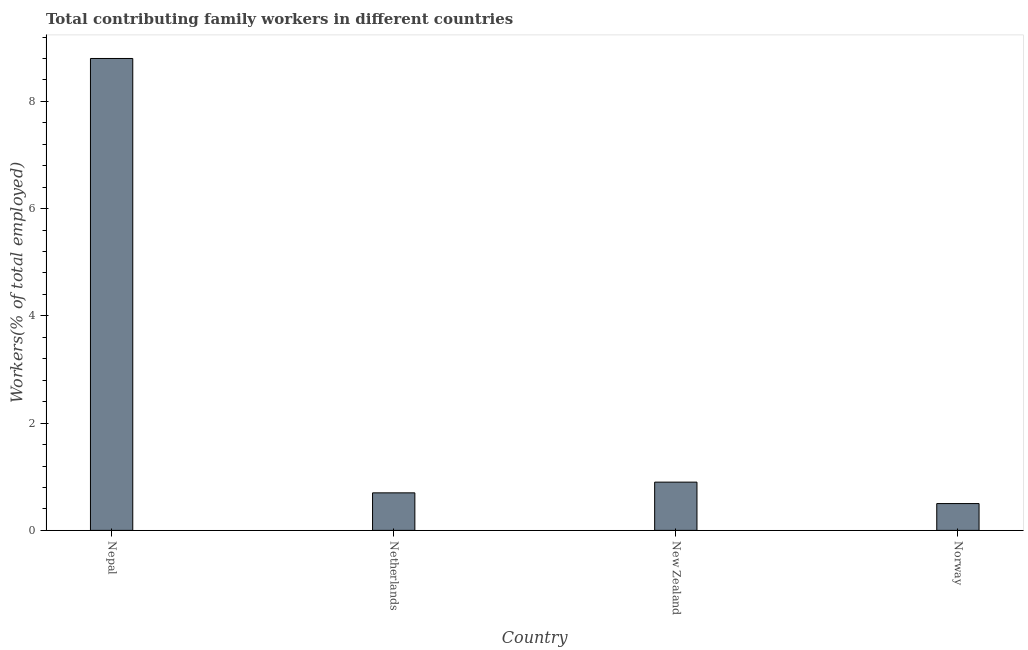Does the graph contain any zero values?
Your answer should be very brief. No. Does the graph contain grids?
Keep it short and to the point. No. What is the title of the graph?
Offer a terse response. Total contributing family workers in different countries. What is the label or title of the X-axis?
Your answer should be compact. Country. What is the label or title of the Y-axis?
Offer a terse response. Workers(% of total employed). What is the contributing family workers in Netherlands?
Your answer should be compact. 0.7. Across all countries, what is the maximum contributing family workers?
Offer a terse response. 8.8. In which country was the contributing family workers maximum?
Your answer should be very brief. Nepal. What is the sum of the contributing family workers?
Ensure brevity in your answer.  10.9. What is the average contributing family workers per country?
Your answer should be very brief. 2.73. What is the median contributing family workers?
Your response must be concise. 0.8. What is the ratio of the contributing family workers in Netherlands to that in New Zealand?
Offer a terse response. 0.78. Is the difference between the contributing family workers in Netherlands and Norway greater than the difference between any two countries?
Keep it short and to the point. No. What is the difference between the highest and the second highest contributing family workers?
Give a very brief answer. 7.9. Is the sum of the contributing family workers in Netherlands and New Zealand greater than the maximum contributing family workers across all countries?
Offer a very short reply. No. What is the difference between the highest and the lowest contributing family workers?
Your answer should be compact. 8.3. How many bars are there?
Keep it short and to the point. 4. Are all the bars in the graph horizontal?
Your answer should be very brief. No. How many countries are there in the graph?
Keep it short and to the point. 4. Are the values on the major ticks of Y-axis written in scientific E-notation?
Make the answer very short. No. What is the Workers(% of total employed) of Nepal?
Ensure brevity in your answer.  8.8. What is the Workers(% of total employed) in Netherlands?
Offer a terse response. 0.7. What is the Workers(% of total employed) of New Zealand?
Your answer should be compact. 0.9. What is the Workers(% of total employed) of Norway?
Keep it short and to the point. 0.5. What is the difference between the Workers(% of total employed) in Nepal and New Zealand?
Your answer should be compact. 7.9. What is the difference between the Workers(% of total employed) in Nepal and Norway?
Give a very brief answer. 8.3. What is the difference between the Workers(% of total employed) in Netherlands and New Zealand?
Make the answer very short. -0.2. What is the difference between the Workers(% of total employed) in New Zealand and Norway?
Keep it short and to the point. 0.4. What is the ratio of the Workers(% of total employed) in Nepal to that in Netherlands?
Your answer should be very brief. 12.57. What is the ratio of the Workers(% of total employed) in Nepal to that in New Zealand?
Make the answer very short. 9.78. What is the ratio of the Workers(% of total employed) in Netherlands to that in New Zealand?
Make the answer very short. 0.78. What is the ratio of the Workers(% of total employed) in New Zealand to that in Norway?
Your response must be concise. 1.8. 